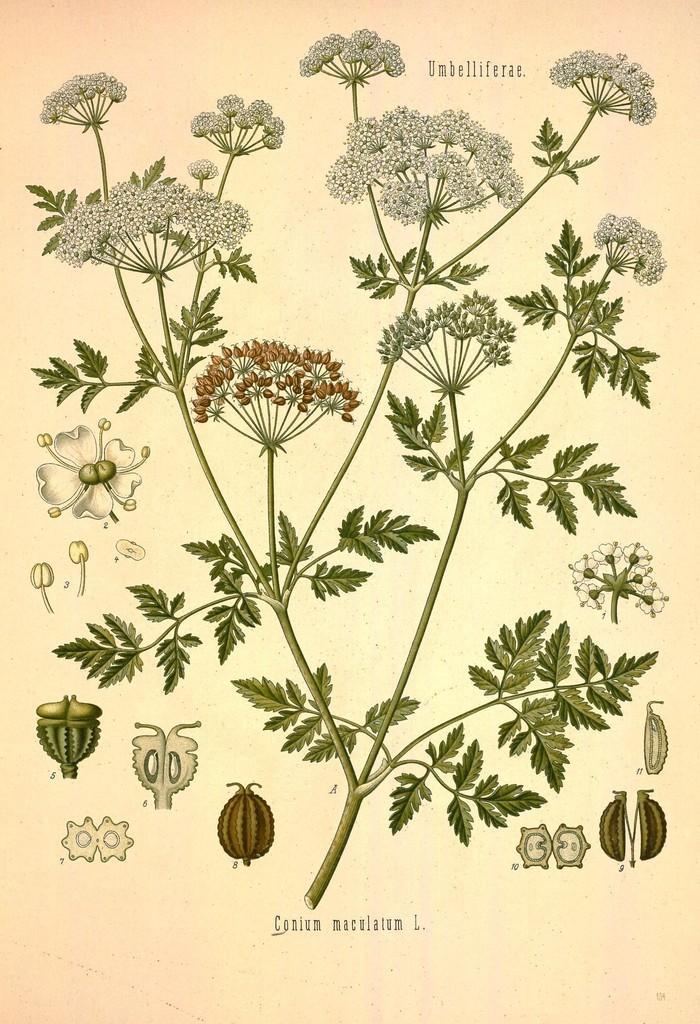What type of artwork is depicted in the image? The image is a painting. What kind of plant can be seen in the painting? There is a plant with flowers in the painting. Are there any unopened flowers on the plant? Yes, there are buds on the plant. What else is featured in the painting besides the plant? There is text present in the painting. What type of music is the band playing in the painting? There is no band present in the painting; it features a plant with flowers and text. 